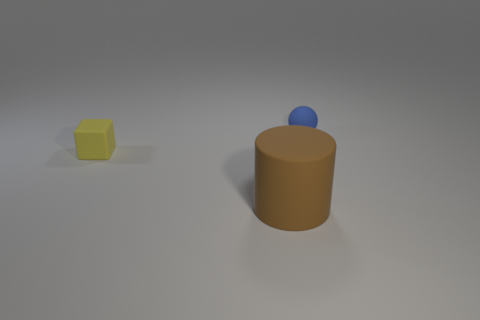What number of balls have the same material as the cube?
Provide a short and direct response. 1. There is a small ball; how many yellow rubber blocks are to the right of it?
Make the answer very short. 0. Do the small thing that is on the right side of the yellow rubber thing and the object that is in front of the tiny yellow block have the same material?
Your answer should be very brief. Yes. Are there more big brown matte cylinders behind the small blue rubber thing than yellow objects that are in front of the tiny yellow block?
Provide a succinct answer. No. Are there any other things that have the same shape as the yellow rubber object?
Provide a succinct answer. No. What is the material of the thing that is to the right of the yellow matte cube and left of the ball?
Your response must be concise. Rubber. Does the small yellow cube have the same material as the tiny object that is behind the tiny yellow thing?
Offer a very short reply. Yes. Is there anything else that has the same size as the brown thing?
Your answer should be very brief. No. How many objects are either large brown cubes or matte things that are in front of the yellow rubber block?
Offer a terse response. 1. There is a rubber thing that is to the left of the brown thing; does it have the same size as the thing that is on the right side of the brown matte cylinder?
Offer a terse response. Yes. 